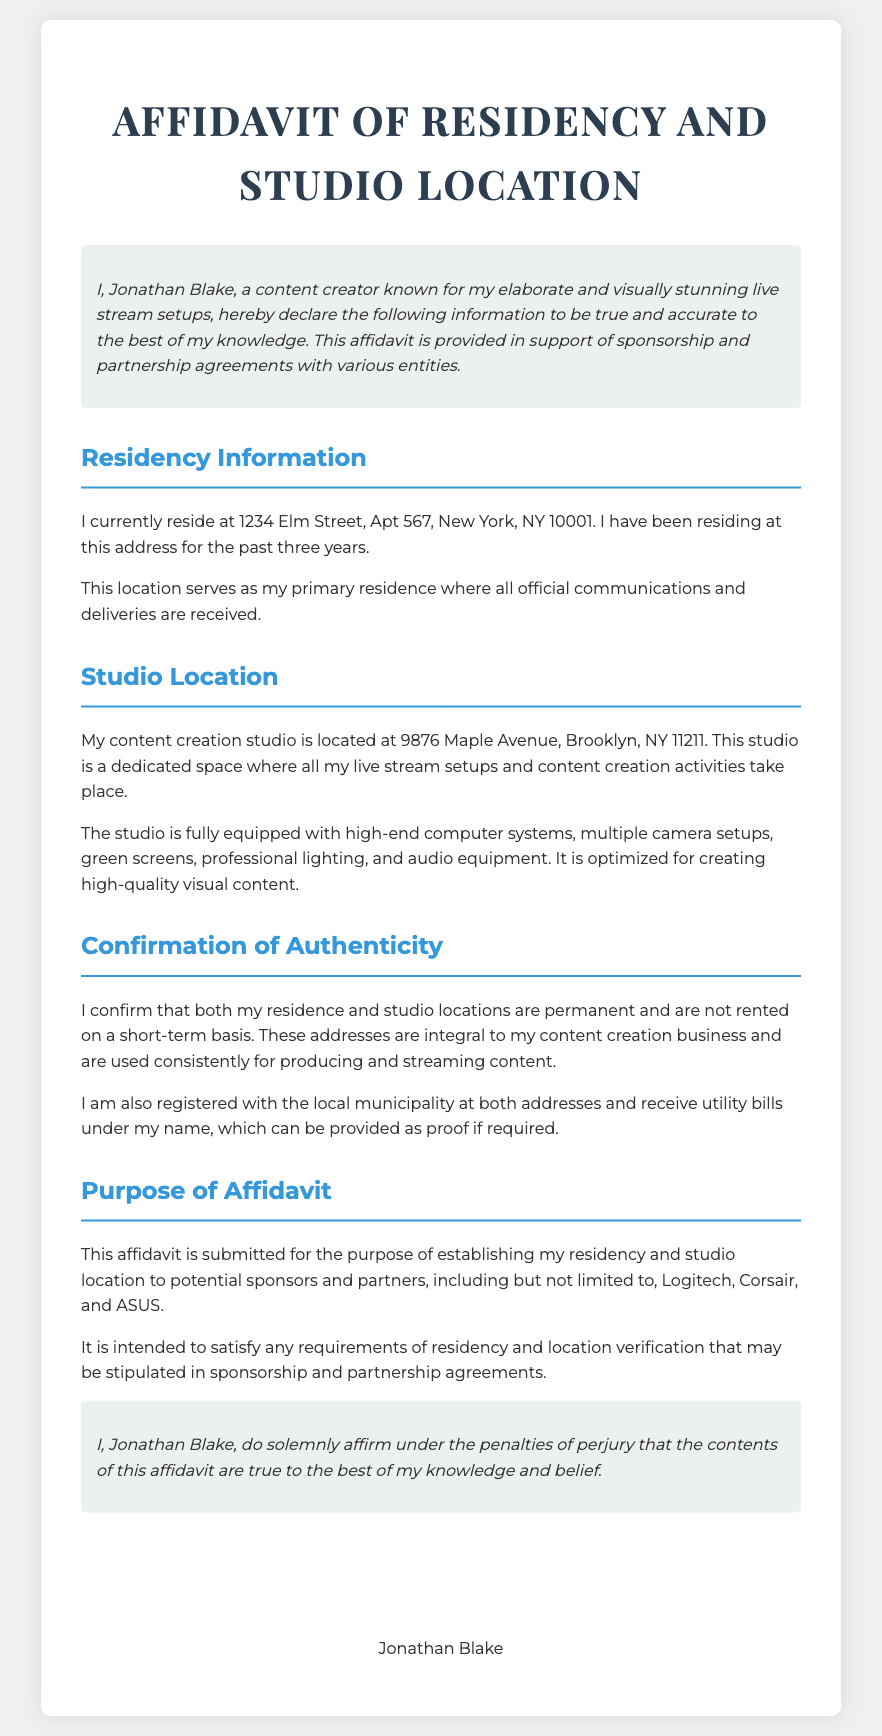What is the name of the content creator? The name of the content creator is mentioned in the introduction of the affidavit.
Answer: Jonathan Blake How long has Jonathan Blake resided at his current address? The document explicitly states the duration of residence at the given address.
Answer: Three years What is Jonathan Blake's studio location? The affidavit clearly details the address of the studio where content creation occurs.
Answer: 9876 Maple Avenue, Brooklyn, NY 11211 What types of equipment are mentioned as being in the studio? The types of equipment used for content creation are listed in the studio location section of the affidavit.
Answer: High-end computer systems, multiple camera setups, green screens, professional lighting, audio equipment What is the purpose of this affidavit? The purpose of the affidavit is stated in a specific section aimed at establishing residency and location.
Answer: Establishing residency and studio location for sponsorship agreements What utilities does Jonathan Blake receive bills for? The document mentions the registration of both addresses and the associated bills that can be provided as proof.
Answer: Utility bills What entities is this affidavit intended to support? The names of potential sponsors and partners are included in the purpose section of the affidavit.
Answer: Logitech, Corsair, ASUS What confirmation does Jonathan Blake provide regarding his residence? The document states Jonathan Blake's confirmation about the nature of his residency.
Answer: Permanent residence How does the document conclude? The concluding section summarizes the affirmation made by Jonathan Blake.
Answer: Solemnly affirm under penalties of perjury 